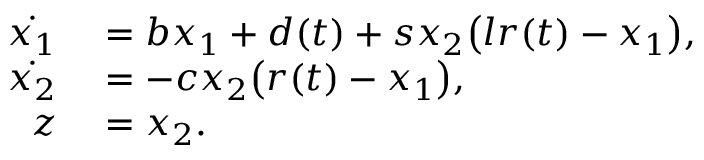Convert formula to latex. <formula><loc_0><loc_0><loc_500><loc_500>\begin{array} { r l } { \dot { x _ { 1 } } } & = b x _ { 1 } + d ( t ) + s x _ { 2 } \left ( l r ( t ) - x _ { 1 } \right ) , } \\ { \dot { x _ { 2 } } } & = - c x _ { 2 } \left ( r ( t ) - x _ { 1 } \right ) , } \\ { z } & = x _ { 2 } . } \end{array}</formula> 